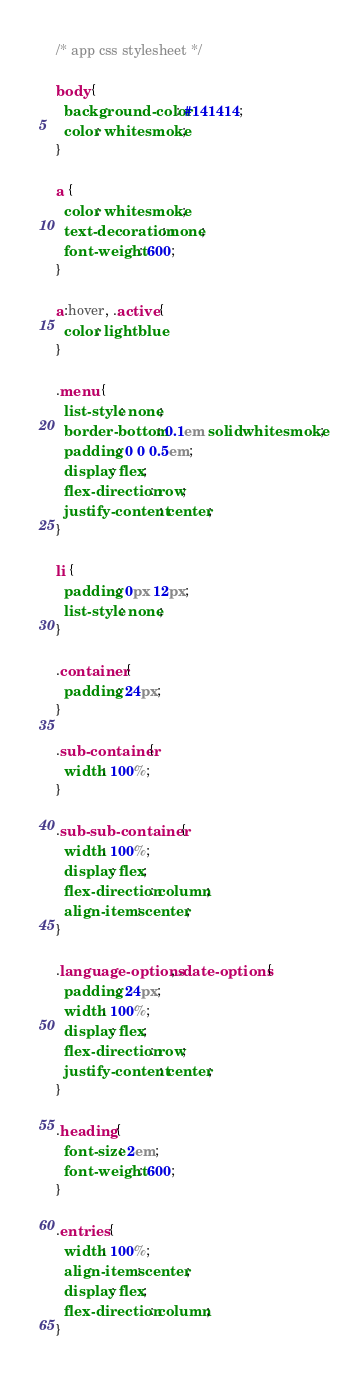<code> <loc_0><loc_0><loc_500><loc_500><_CSS_>/* app css stylesheet */

body {
  background-color: #141414;
  color: whitesmoke;
}

a {
  color: whitesmoke;
  text-decoration: none;
  font-weight: 600;
}

a:hover, .active {
  color: lightblue
}

.menu {
  list-style: none;
  border-bottom: 0.1em solid whitesmoke;
  padding: 0 0 0.5em;
  display: flex;
  flex-direction: row;
  justify-content: center;
}

li {
  padding: 0px 12px;
  list-style: none;
}

.container {
  padding: 24px;
}

.sub-container{
  width: 100%;
}

.sub-sub-container {
  width: 100%;
  display: flex;
  flex-direction: column;
  align-items: center;
}

.language-options, .date-options {
  padding: 24px;
  width: 100%;
  display: flex;
  flex-direction: row;
  justify-content: center;
}

.heading {
  font-size: 2em;
  font-weight: 600;
}

.entries {
  width: 100%;
  align-items: center;
  display: flex;
  flex-direction: column;
}</code> 